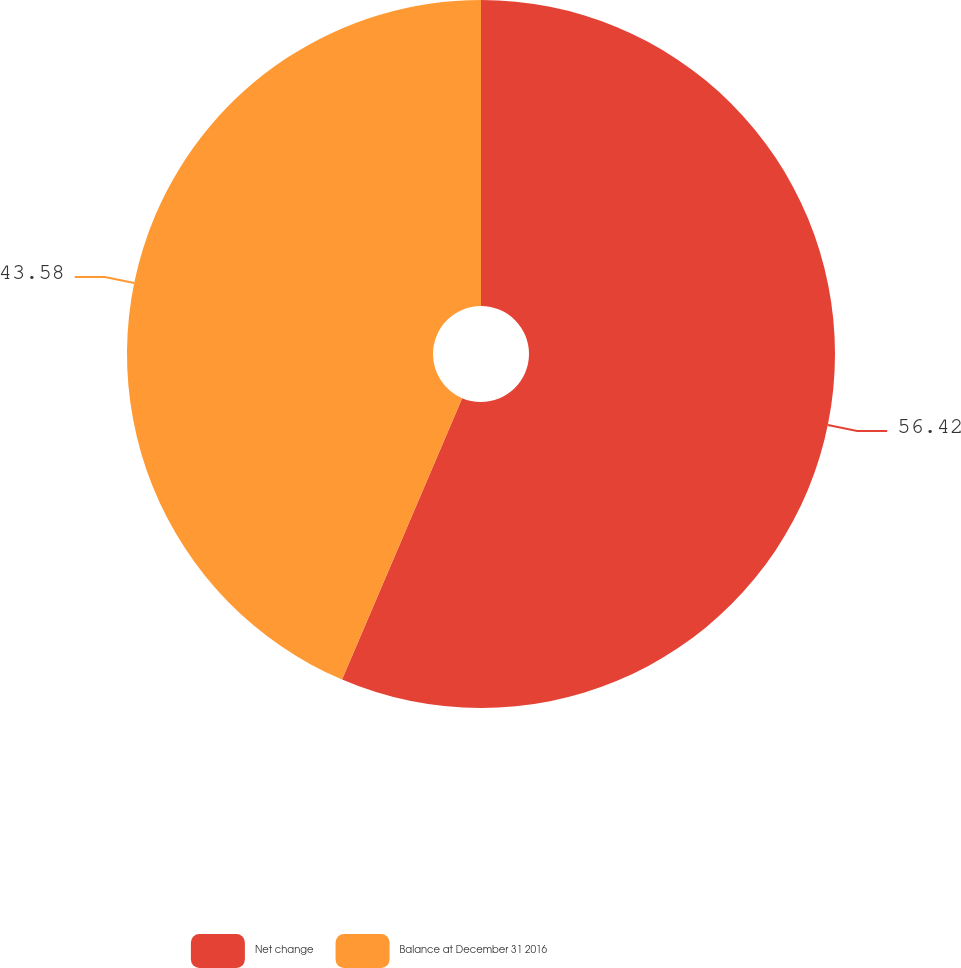Convert chart. <chart><loc_0><loc_0><loc_500><loc_500><pie_chart><fcel>Net change<fcel>Balance at December 31 2016<nl><fcel>56.42%<fcel>43.58%<nl></chart> 